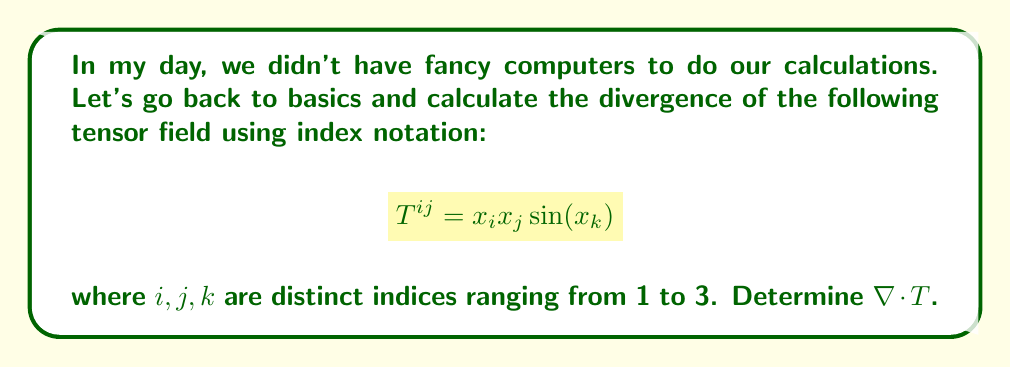Could you help me with this problem? Let's approach this step-by-step, just like we did in the good old days:

1) The divergence of a tensor field $T^{ij}$ in index notation is given by:

   $$\nabla \cdot T = \frac{\partial T^{ij}}{\partial x_i}$$

2) We need to apply the product rule and the chain rule:

   $$\frac{\partial T^{ij}}{\partial x_i} = \frac{\partial}{\partial x_i}(x_i x_j \sin(x_k))$$
   
   $$= x_j \sin(x_k) \frac{\partial x_i}{\partial x_i} + x_i \sin(x_k) \frac{\partial x_j}{\partial x_i} + x_i x_j \cos(x_k) \frac{\partial x_k}{\partial x_i}$$

3) Simplify:
   - $\frac{\partial x_i}{\partial x_i} = 1$
   - $\frac{\partial x_j}{\partial x_i} = 0$ (since $i \neq j$)
   - $\frac{\partial x_k}{\partial x_i} = 0$ (since $i \neq k$)

4) Therefore:

   $$\frac{\partial T^{ij}}{\partial x_i} = x_j \sin(x_k) + 0 + 0 = x_j \sin(x_k)$$

5) Now, we need to sum over $i$ and $j$ (remember, $i \neq j$):

   $$\nabla \cdot T = \sum_{i \neq j} x_j \sin(x_k)$$

6) There are 6 combinations where $i \neq j$ (12, 13, 21, 23, 31, 32), so:

   $$\nabla \cdot T = 2(x_1 \sin(x_3) + x_2 \sin(x_1) + x_3 \sin(x_2))$$

This is our final result.
Answer: $$2(x_1 \sin(x_3) + x_2 \sin(x_1) + x_3 \sin(x_2))$$ 